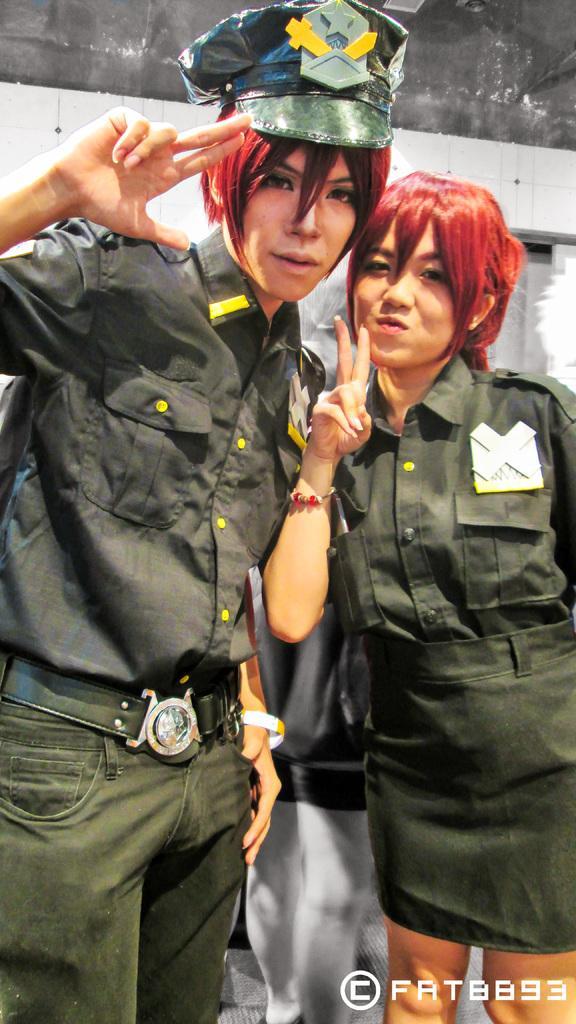Please provide a concise description of this image. In the foreground of this picture, there is a man and a woman in green dress, standing and posing to a camera. In the background, there is a wall and a person. 